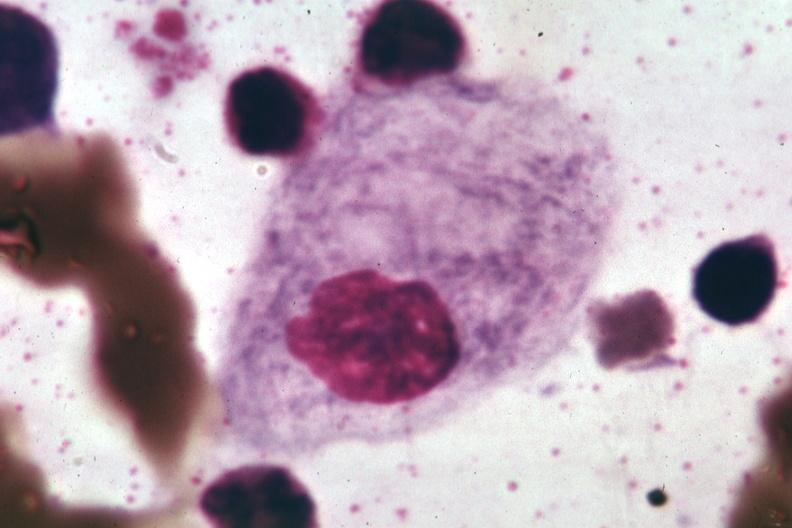s hematologic present?
Answer the question using a single word or phrase. Yes 